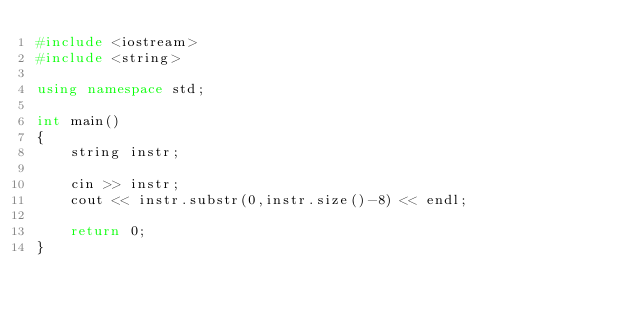<code> <loc_0><loc_0><loc_500><loc_500><_C++_>#include <iostream>
#include <string>

using namespace std;

int main()
{
    string instr;

    cin >> instr;
    cout << instr.substr(0,instr.size()-8) << endl;

    return 0;
}
</code> 